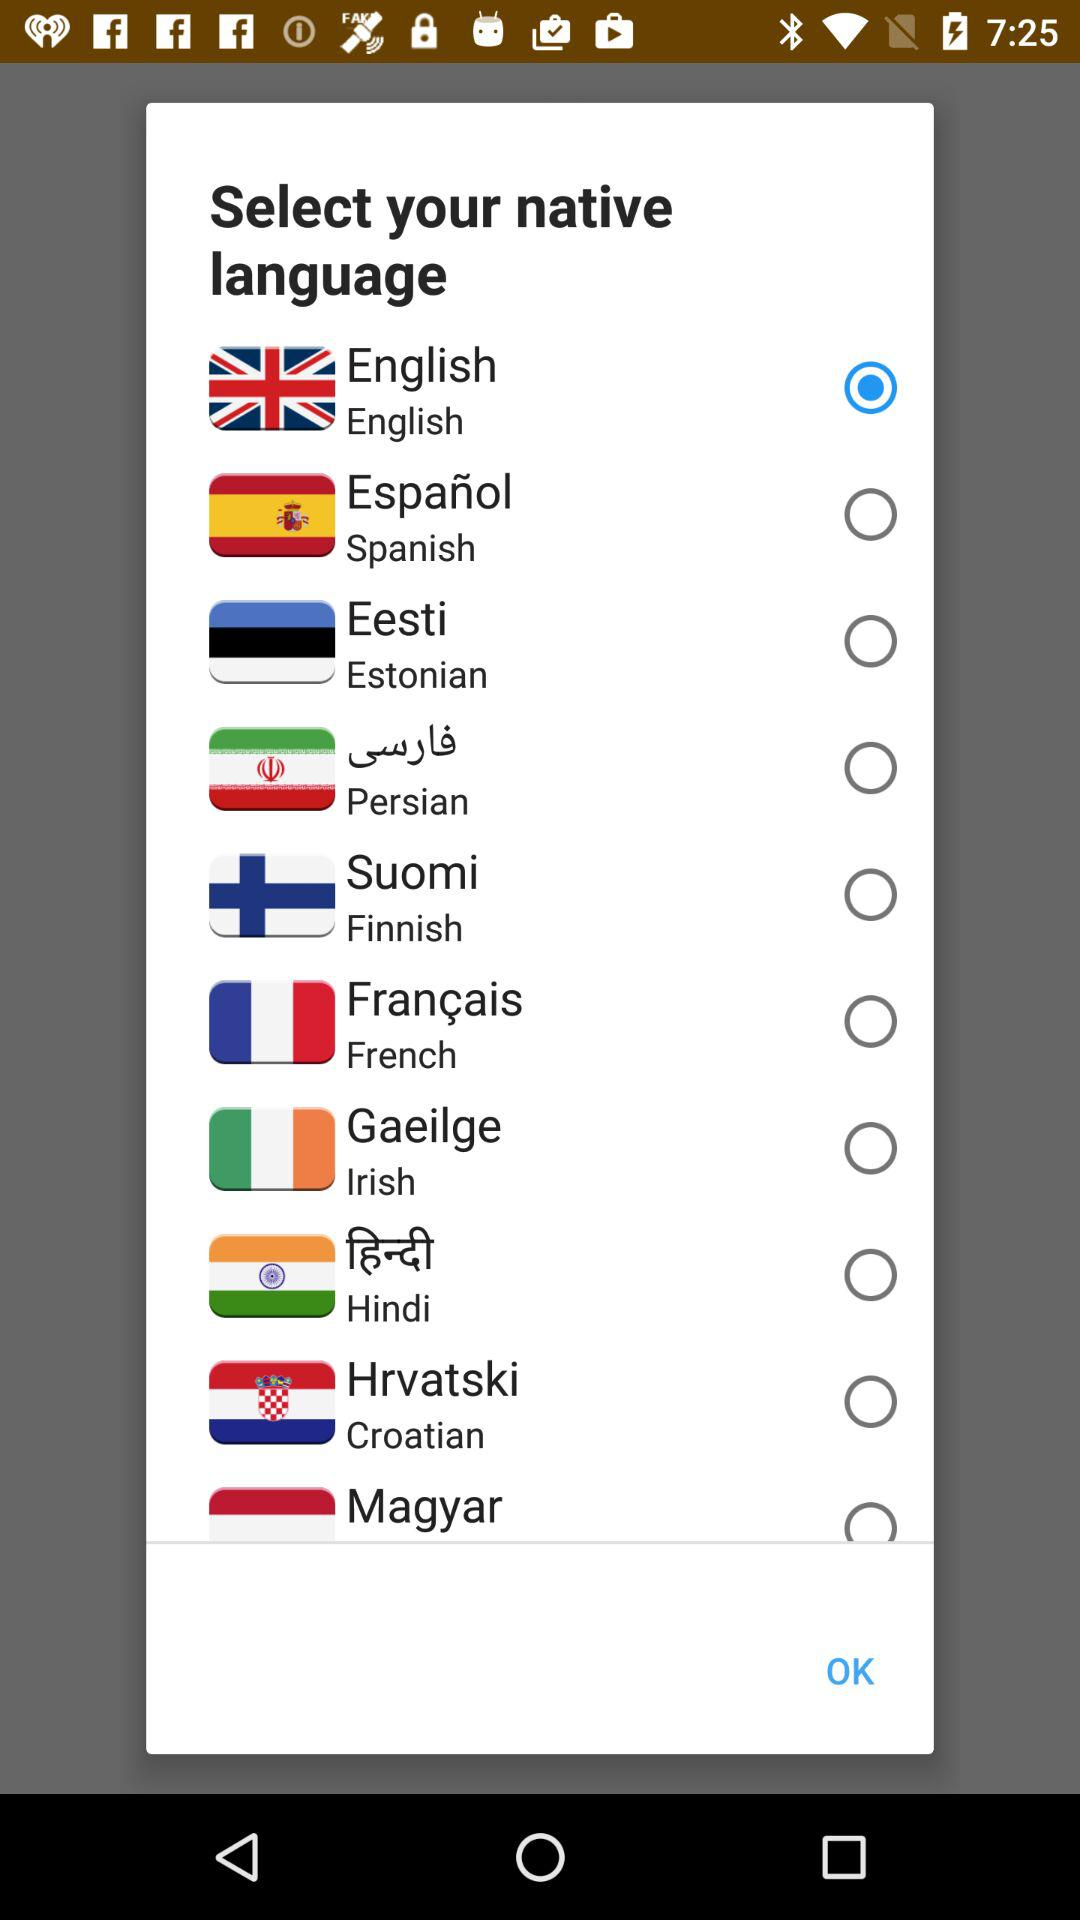How many languages are available to select?
Answer the question using a single word or phrase. 10 